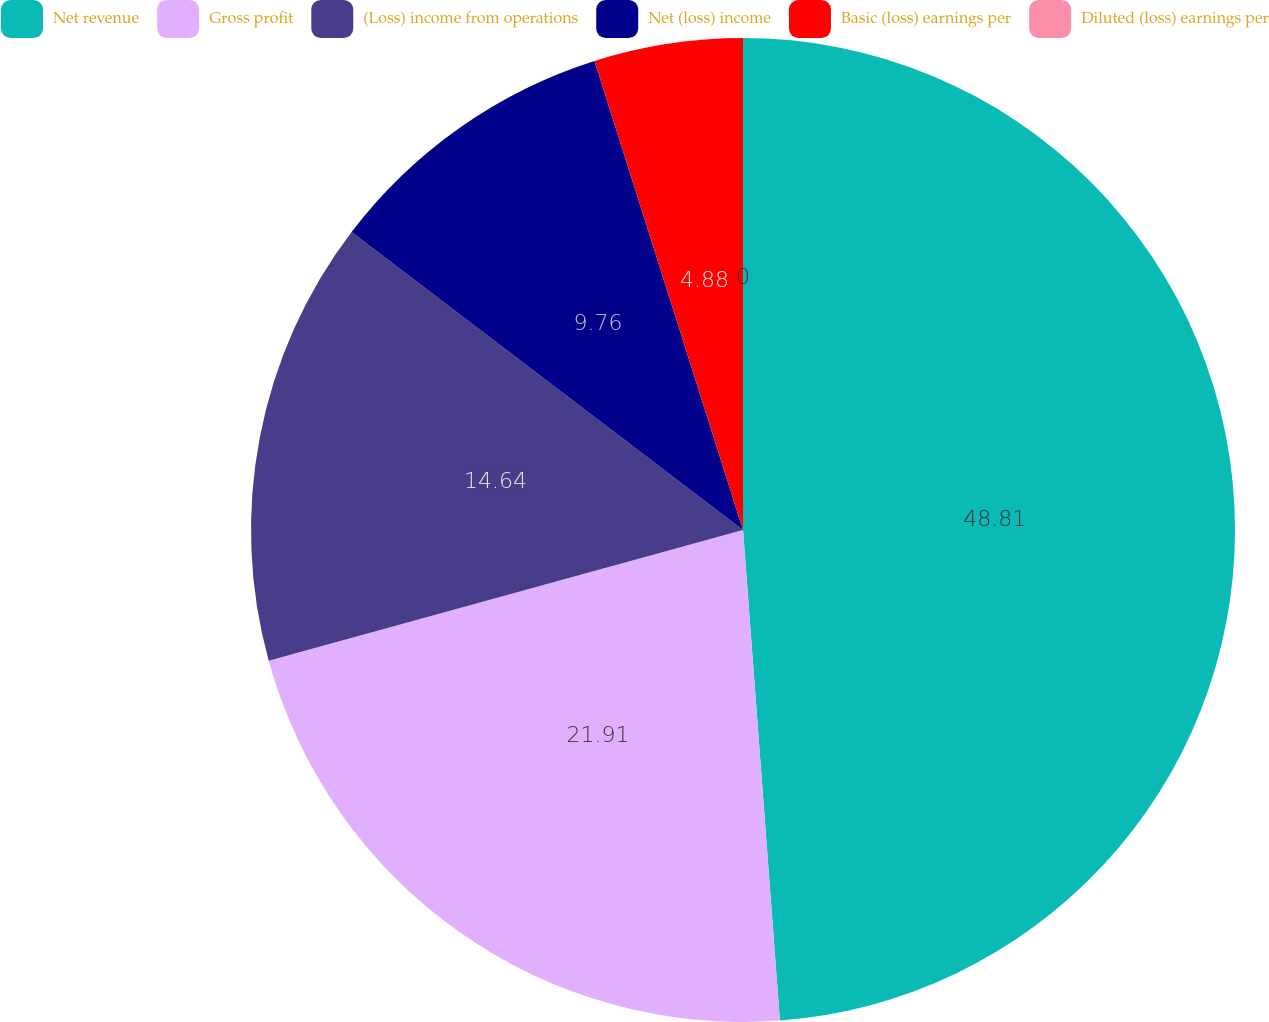Convert chart to OTSL. <chart><loc_0><loc_0><loc_500><loc_500><pie_chart><fcel>Net revenue<fcel>Gross profit<fcel>(Loss) income from operations<fcel>Net (loss) income<fcel>Basic (loss) earnings per<fcel>Diluted (loss) earnings per<nl><fcel>48.8%<fcel>21.91%<fcel>14.64%<fcel>9.76%<fcel>4.88%<fcel>0.0%<nl></chart> 